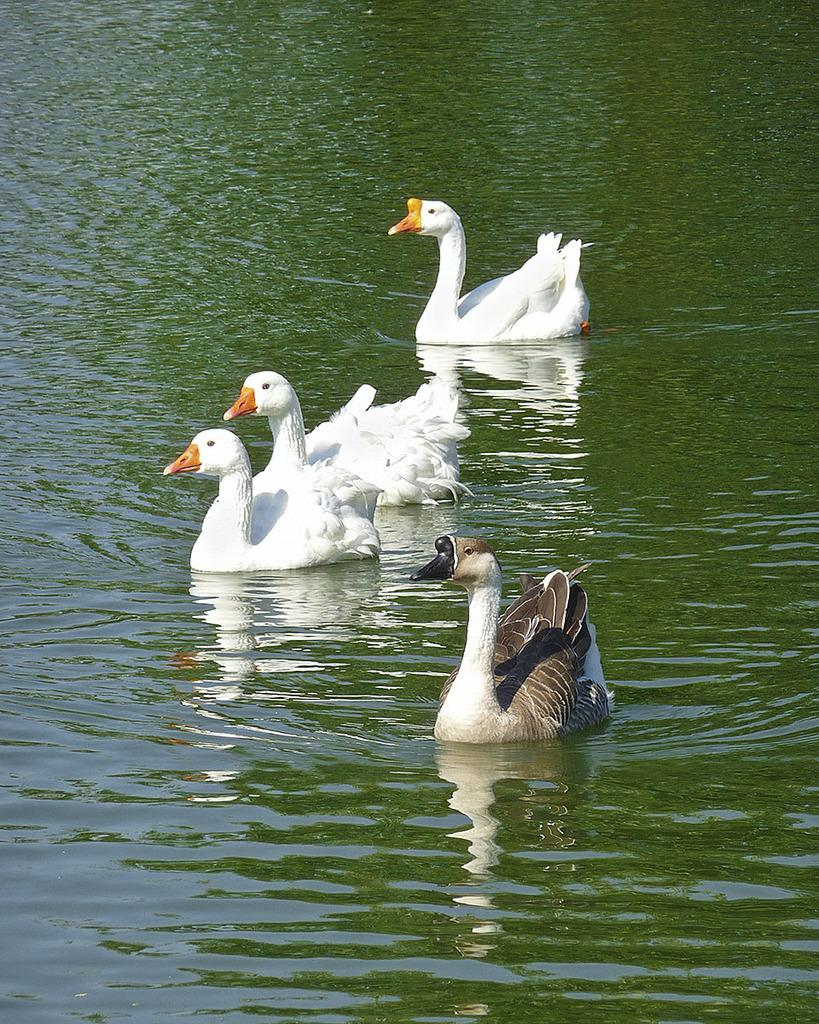What type of animals can be seen in the image? There are ducks in the image. Where are the ducks located? The ducks are in the water. What type of weather can be seen in the image? The image does not show any indication of the weather, as it features ducks in the water. 